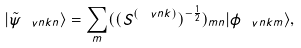Convert formula to latex. <formula><loc_0><loc_0><loc_500><loc_500>| \tilde { \psi } _ { \ v n { k } n } \rangle = \sum _ { m } ( ( S ^ { ( \ v n { k } ) } ) ^ { - \frac { 1 } { 2 } } ) _ { m n } | \phi _ { \ v n { k } m } \rangle ,</formula> 